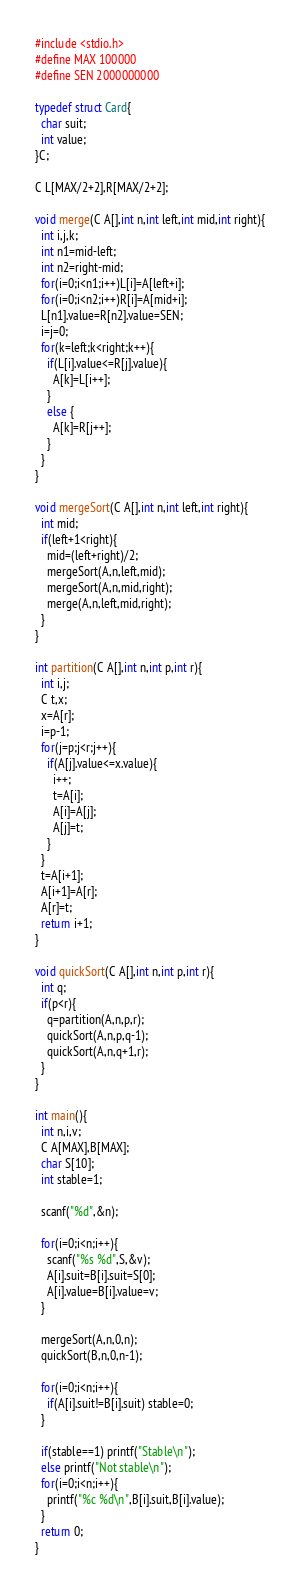Convert code to text. <code><loc_0><loc_0><loc_500><loc_500><_C_>#include <stdio.h>
#define MAX 100000
#define SEN 2000000000

typedef struct Card{
  char suit;
  int value;
}C;

C L[MAX/2+2],R[MAX/2+2];

void merge(C A[],int n,int left,int mid,int right){
  int i,j,k;
  int n1=mid-left;
  int n2=right-mid;
  for(i=0;i<n1;i++)L[i]=A[left+i];
  for(i=0;i<n2;i++)R[i]=A[mid+i];
  L[n1].value=R[n2].value=SEN;
  i=j=0;
  for(k=left;k<right;k++){
    if(L[i].value<=R[j].value){
      A[k]=L[i++];
    }
    else {
      A[k]=R[j++];
    }
  }
}

void mergeSort(C A[],int n,int left,int right){
  int mid;
  if(left+1<right){
    mid=(left+right)/2;
    mergeSort(A,n,left,mid);
    mergeSort(A,n,mid,right);
    merge(A,n,left,mid,right);
  }
}

int partition(C A[],int n,int p,int r){
  int i,j;
  C t,x;
  x=A[r];
  i=p-1;
  for(j=p;j<r;j++){
    if(A[j].value<=x.value){
      i++;
      t=A[i];
      A[i]=A[j];
      A[j]=t;
    }
  }
  t=A[i+1];
  A[i+1]=A[r];
  A[r]=t;
  return i+1;
}

void quickSort(C A[],int n,int p,int r){
  int q;
  if(p<r){
    q=partition(A,n,p,r);
    quickSort(A,n,p,q-1);
    quickSort(A,n,q+1,r);
  }
}

int main(){
  int n,i,v;
  C A[MAX],B[MAX];
  char S[10];
  int stable=1;
  
  scanf("%d",&n);
  
  for(i=0;i<n;i++){
    scanf("%s %d",S,&v);
    A[i].suit=B[i].suit=S[0];
    A[i].value=B[i].value=v;
  }
  
  mergeSort(A,n,0,n);
  quickSort(B,n,0,n-1);
  
  for(i=0;i<n;i++){
    if(A[i].suit!=B[i].suit) stable=0;
  }
  
  if(stable==1) printf("Stable\n");
  else printf("Not stable\n");
  for(i=0;i<n;i++){
    printf("%c %d\n",B[i].suit,B[i].value);
  }
  return 0;
}

</code> 